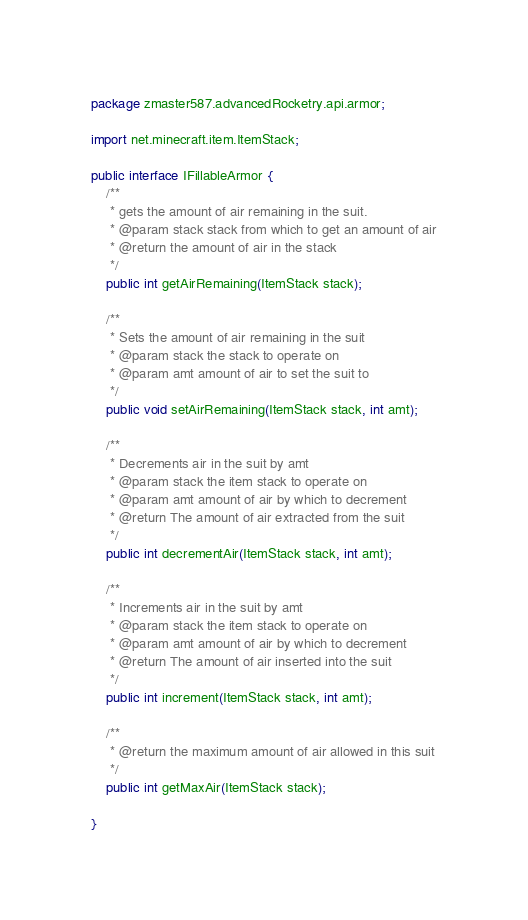Convert code to text. <code><loc_0><loc_0><loc_500><loc_500><_Java_>package zmaster587.advancedRocketry.api.armor;

import net.minecraft.item.ItemStack;

public interface IFillableArmor {
	/**
	 * gets the amount of air remaining in the suit.
	 * @param stack stack from which to get an amount of air
	 * @return the amount of air in the stack
	 */
	public int getAirRemaining(ItemStack stack);
	
	/**
	 * Sets the amount of air remaining in the suit
	 * @param stack the stack to operate on
	 * @param amt amount of air to set the suit to
	 */
	public void setAirRemaining(ItemStack stack, int amt);
	
	/**
	 * Decrements air in the suit by amt
	 * @param stack the item stack to operate on
	 * @param amt amount of air by which to decrement
	 * @return The amount of air extracted from the suit
	 */
	public int decrementAir(ItemStack stack, int amt);
	
	/**
	 * Increments air in the suit by amt
	 * @param stack the item stack to operate on
	 * @param amt amount of air by which to decrement
	 * @return The amount of air inserted into the suit
	 */
	public int increment(ItemStack stack, int amt);
	
	/**
	 * @return the maximum amount of air allowed in this suit
	 */
	public int getMaxAir(ItemStack stack);
	
}
</code> 